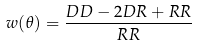Convert formula to latex. <formula><loc_0><loc_0><loc_500><loc_500>w ( \theta ) = \frac { D D - 2 D R + R R } { R R }</formula> 